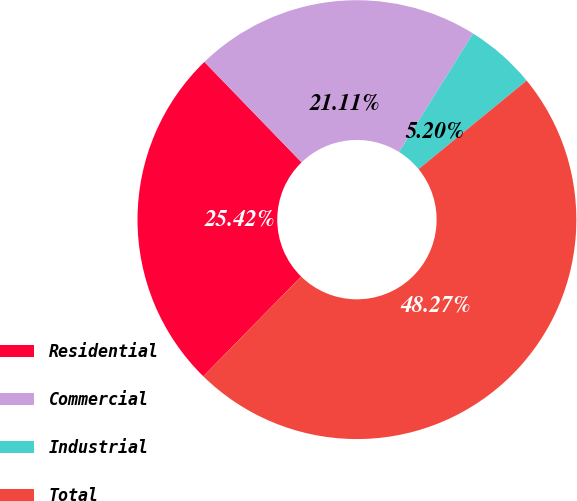Convert chart to OTSL. <chart><loc_0><loc_0><loc_500><loc_500><pie_chart><fcel>Residential<fcel>Commercial<fcel>Industrial<fcel>Total<nl><fcel>25.42%<fcel>21.11%<fcel>5.2%<fcel>48.27%<nl></chart> 